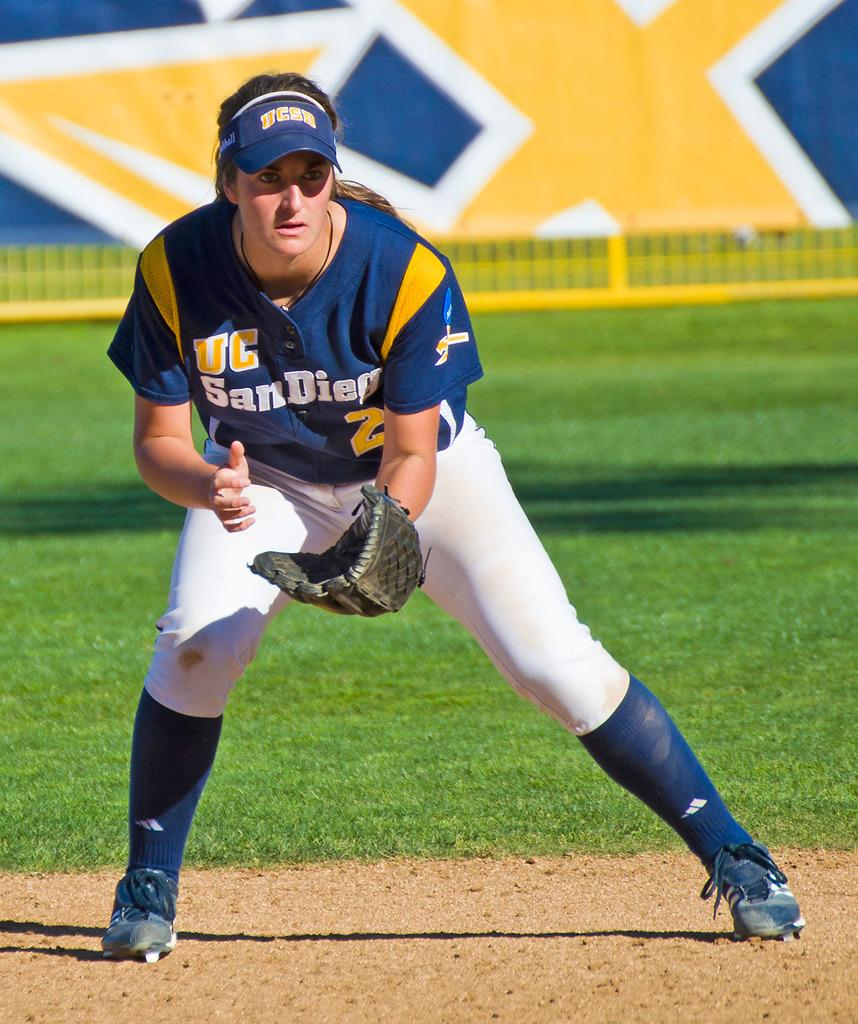<image>
Relay a brief, clear account of the picture shown. The UC San Diego player is ready to catch the ball. 